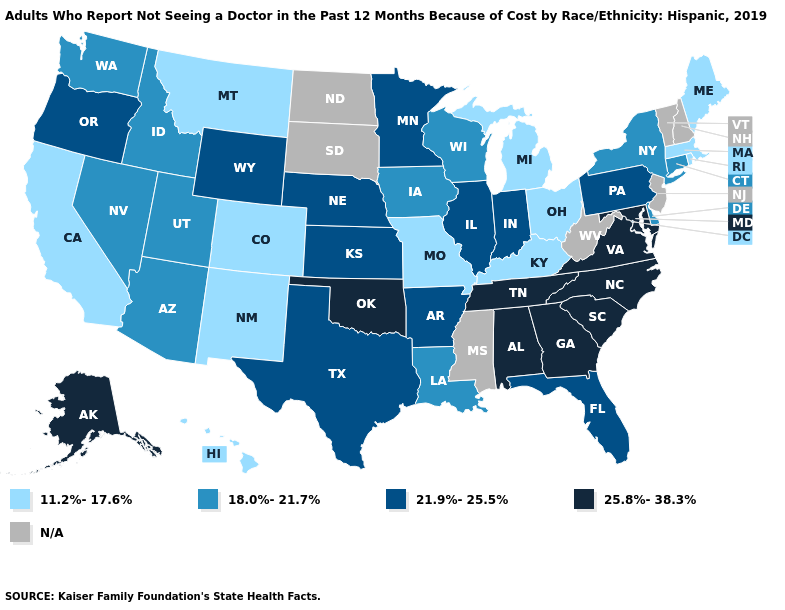Which states hav the highest value in the Northeast?
Write a very short answer. Pennsylvania. Is the legend a continuous bar?
Short answer required. No. What is the value of Wyoming?
Short answer required. 21.9%-25.5%. What is the value of Oklahoma?
Keep it brief. 25.8%-38.3%. Which states have the highest value in the USA?
Give a very brief answer. Alabama, Alaska, Georgia, Maryland, North Carolina, Oklahoma, South Carolina, Tennessee, Virginia. Among the states that border New Mexico , does Colorado have the lowest value?
Answer briefly. Yes. What is the value of Oklahoma?
Write a very short answer. 25.8%-38.3%. What is the lowest value in the USA?
Quick response, please. 11.2%-17.6%. Does the map have missing data?
Write a very short answer. Yes. Name the states that have a value in the range 25.8%-38.3%?
Write a very short answer. Alabama, Alaska, Georgia, Maryland, North Carolina, Oklahoma, South Carolina, Tennessee, Virginia. Does the first symbol in the legend represent the smallest category?
Answer briefly. Yes. What is the value of Montana?
Quick response, please. 11.2%-17.6%. What is the value of West Virginia?
Concise answer only. N/A. What is the value of Tennessee?
Give a very brief answer. 25.8%-38.3%. What is the value of Oklahoma?
Be succinct. 25.8%-38.3%. 